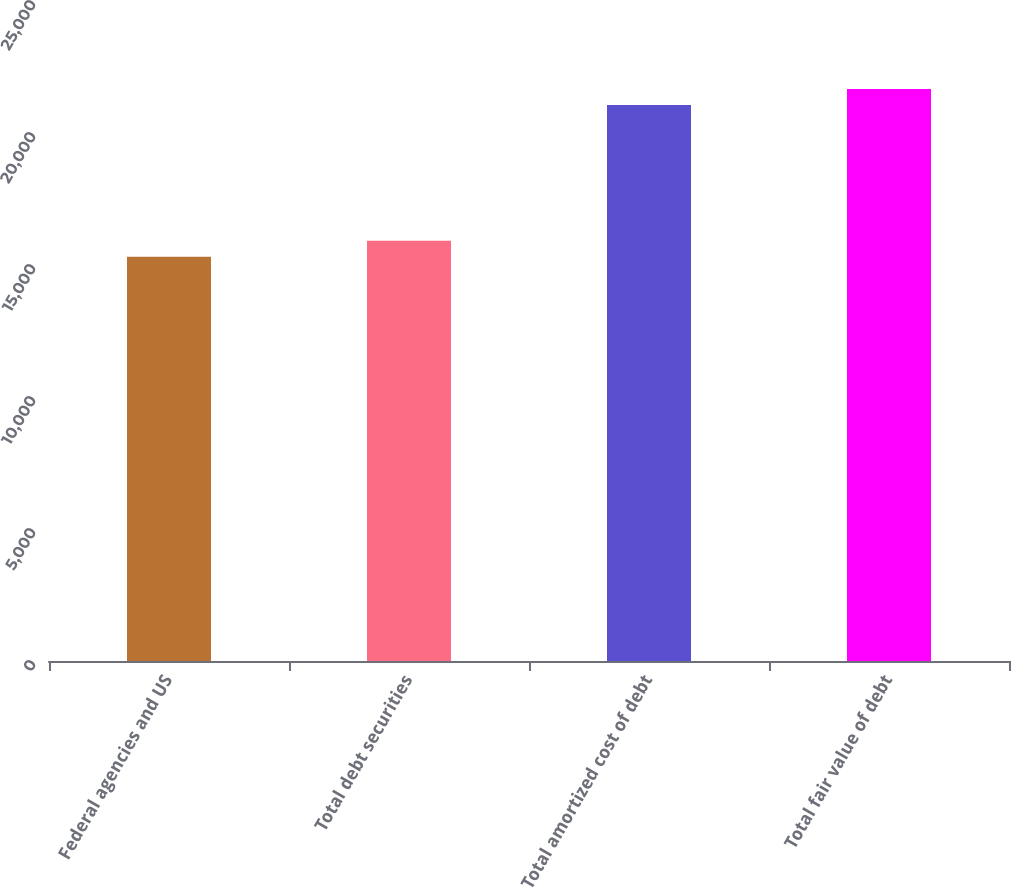Convert chart to OTSL. <chart><loc_0><loc_0><loc_500><loc_500><bar_chart><fcel>Federal agencies and US<fcel>Total debt securities<fcel>Total amortized cost of debt<fcel>Total fair value of debt<nl><fcel>15310<fcel>15915<fcel>21063<fcel>21662.8<nl></chart> 